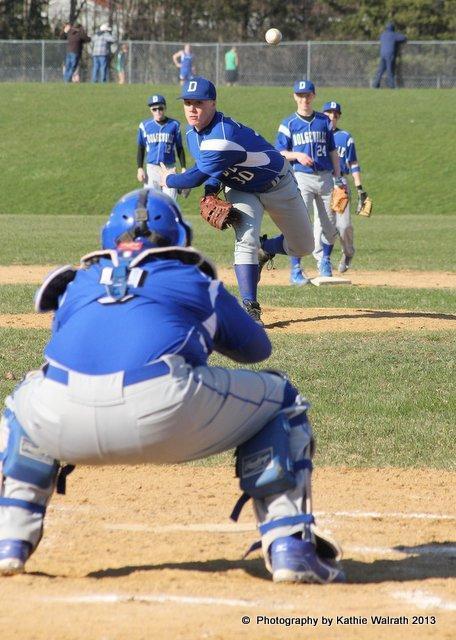How many people are there?
Give a very brief answer. 5. 